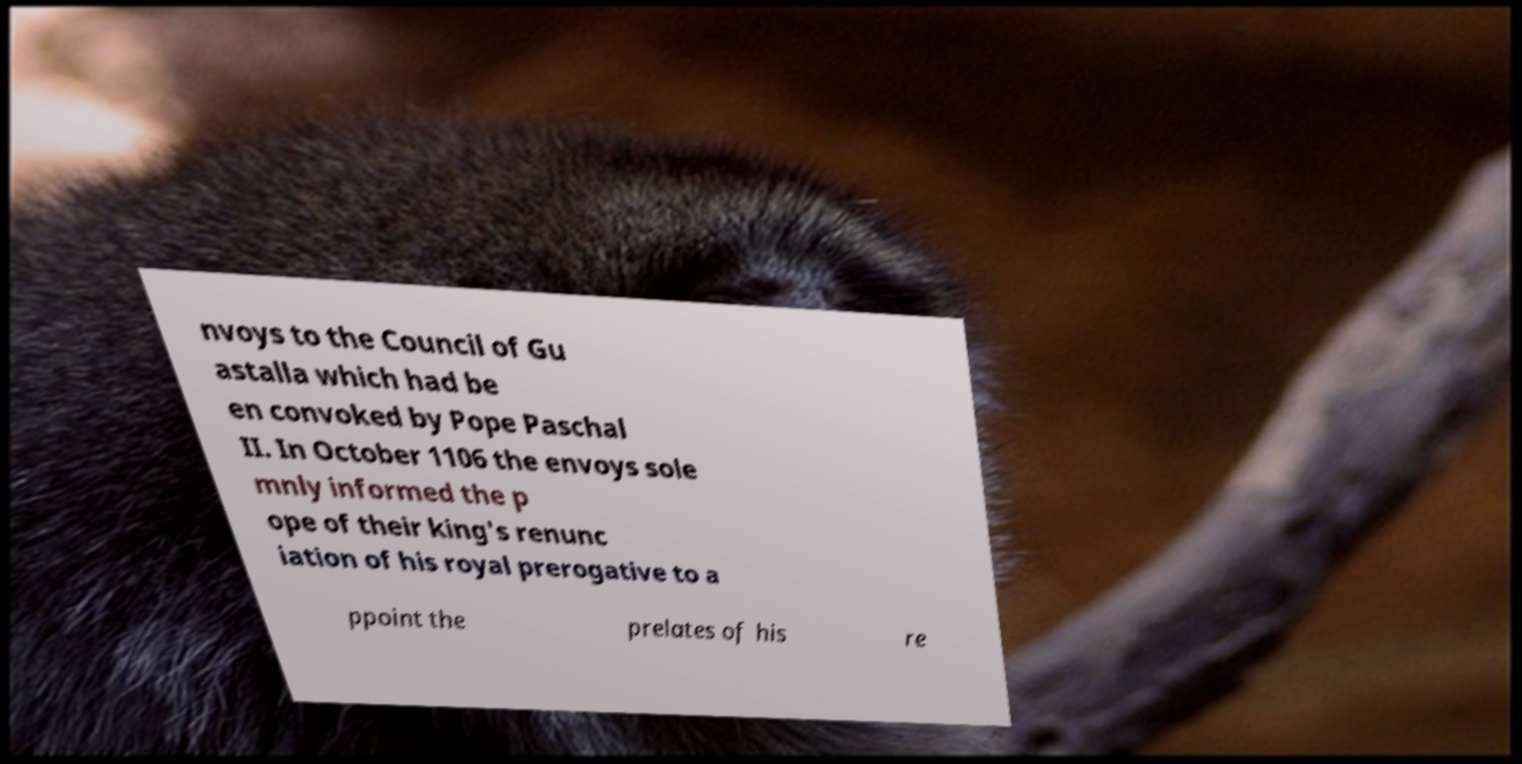Please read and relay the text visible in this image. What does it say? nvoys to the Council of Gu astalla which had be en convoked by Pope Paschal II. In October 1106 the envoys sole mnly informed the p ope of their king's renunc iation of his royal prerogative to a ppoint the prelates of his re 